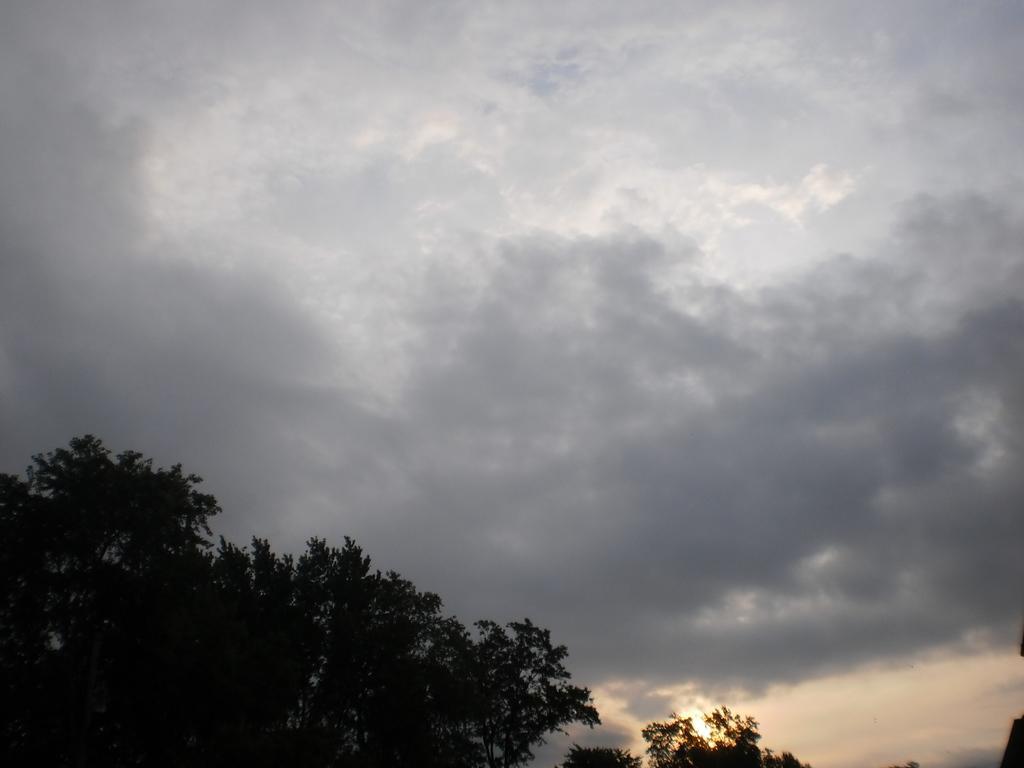Can you describe this image briefly? In this picture, there are trees at the bottom left. On the top, there is a sky. 